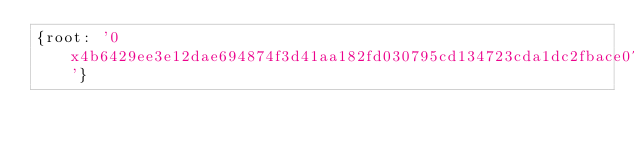<code> <loc_0><loc_0><loc_500><loc_500><_YAML_>{root: '0x4b6429ee3e12dae694874f3d41aa182fd030795cd134723cda1dc2fbace073e4'}
</code> 